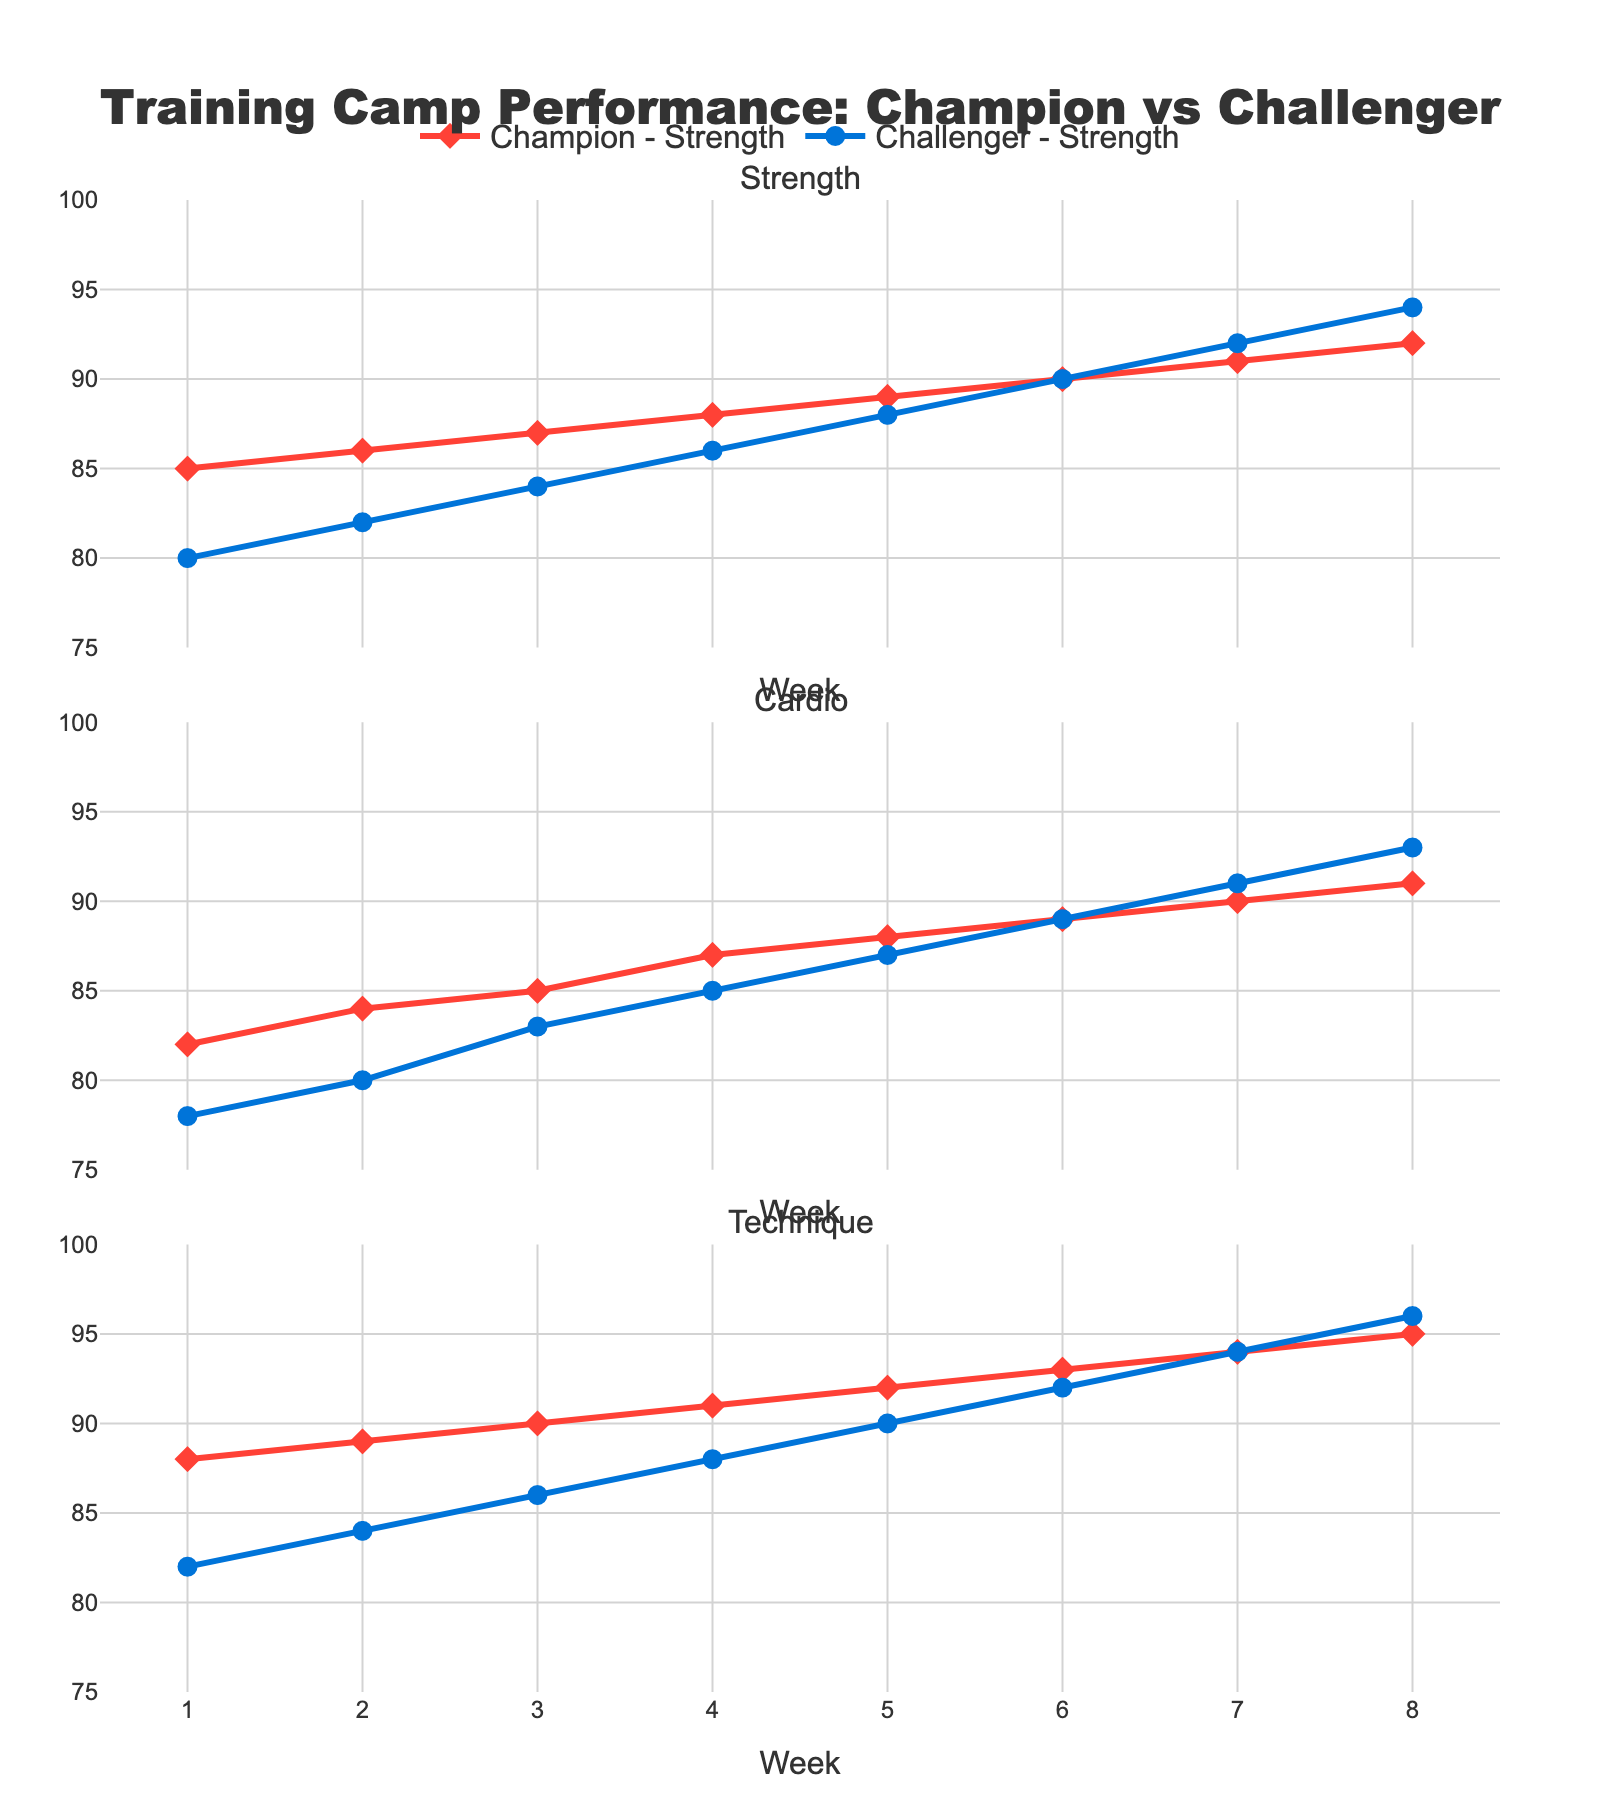What is the difference in the strength score between the Champion and Challenger in week 4? In week 4, the Champion's strength score is 88, and the Challenger's strength score is 86. The difference is calculated as 88 - 86 = 2
Answer: 2 Which fighter showed the most improvement in technique score from week 1 to week 8? The Champion's technique score improved from 88 to 95, which is an improvement of 7 points. The Challenger's technique score improved from 82 to 96, which is an improvement of 14 points. Thus, the Challenger showed the most improvement.
Answer: Challenger Comparing weeks 2 and 7, which fighter had a greater increase in cardio score? For the Champion, the cardio score increased from 84 in week 2 to 90 in week 7, an increase of 6 points. For the Challenger, the cardio score increased from 80 in week 2 to 91 in week 7, an increase of 11 points. Hence, the Challenger had a greater increase.
Answer: Challenger What is the average strength score of the Challenger during the training camp? The strength scores for the Challenger across the 8 weeks are [80, 82, 84, 86, 88, 90, 92, 94]. Adding these scores results in a total of 696. Dividing 696 by 8 gives an average score of 87.
Answer: 87 In which week did both fighters have the same technique score? By examining the technique scores across the weeks, we can see that in week 7, both fighters had a technique score of 94.
Answer: Week 7 Is there any week where the Champion's cardio score did not improve from the previous week? By examining the Champion's cardio scores: [82, 84, 85, 87, 88, 89, 90, 91], we can see that the score consistently improved every week.
Answer: No How do the trends in the strength score of the Champion compare to those of the Challenger over the training camp? The strength scores show an upward trend for both fighters, with the Champion’s scores increasing steadily from 85 to 92 and the Challenger’s from 80 to 94. However, the Challenger’s strength score increases by a larger margin.
Answer: Upward for both, larger margin for Challenger What is the overall trend in technique scores for both fighters from week 1 to week 8? Both fighters exhibit a consistent increase in technique scores. The Champion's score increases from 88 to 95, and the Challenger’s score increases from 82 to 96.
Answer: Consistent increase for both Which week had the smallest difference in cardio scores between the two fighters? By comparing the cardio scores week by week, we find that in week 8, both the Champion and the Challenger had a cardio score of 91 and 93 respectively, resulting in the smallest difference of 2 points.
Answer: Week 8 What is the median strength score of the Champion throughout the training camp? The Champion’s strength scores are [85, 86, 87, 88, 89, 90, 91, 92]. The median is the average of the 4th and 5th values in an ordered list. Therefore, (88+89)/2 = 88.5.
Answer: 88.5 